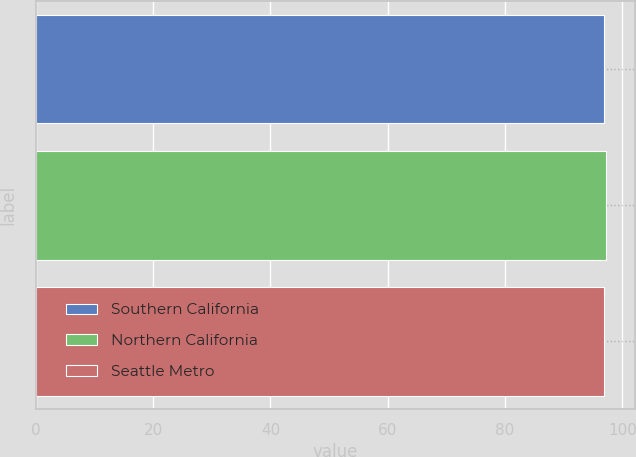Convert chart to OTSL. <chart><loc_0><loc_0><loc_500><loc_500><bar_chart><fcel>Southern California<fcel>Northern California<fcel>Seattle Metro<nl><fcel>96.8<fcel>97.3<fcel>96.9<nl></chart> 